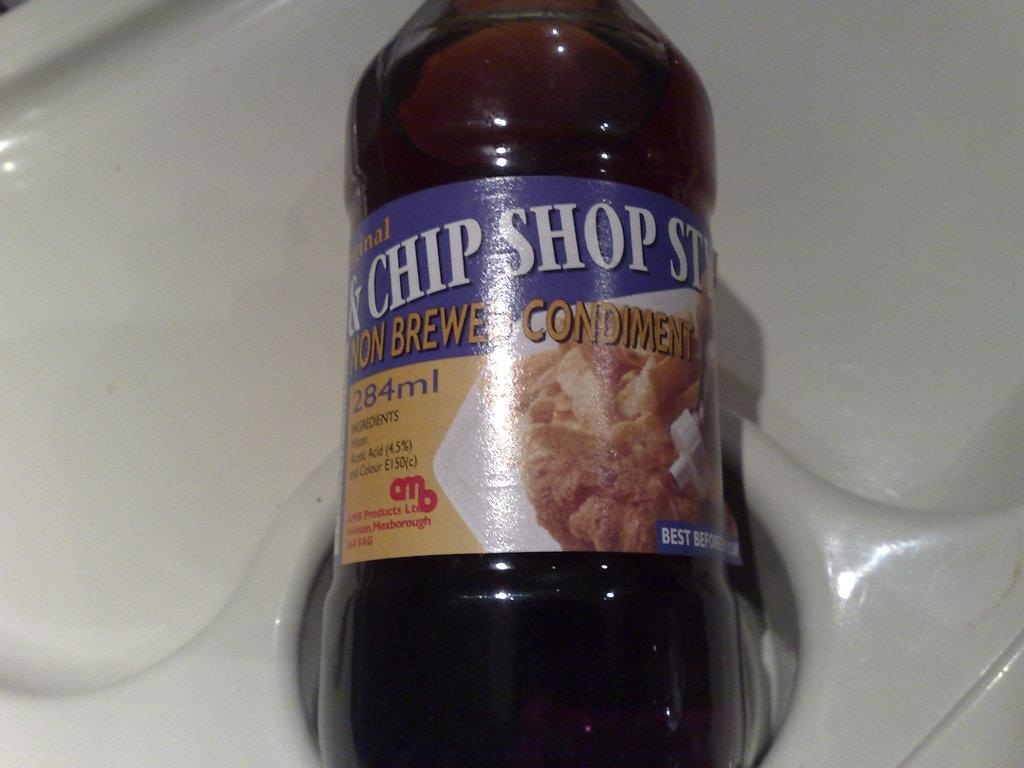<image>
Render a clear and concise summary of the photo. A bottle of Non Brewed Condiment for Chip Shop 